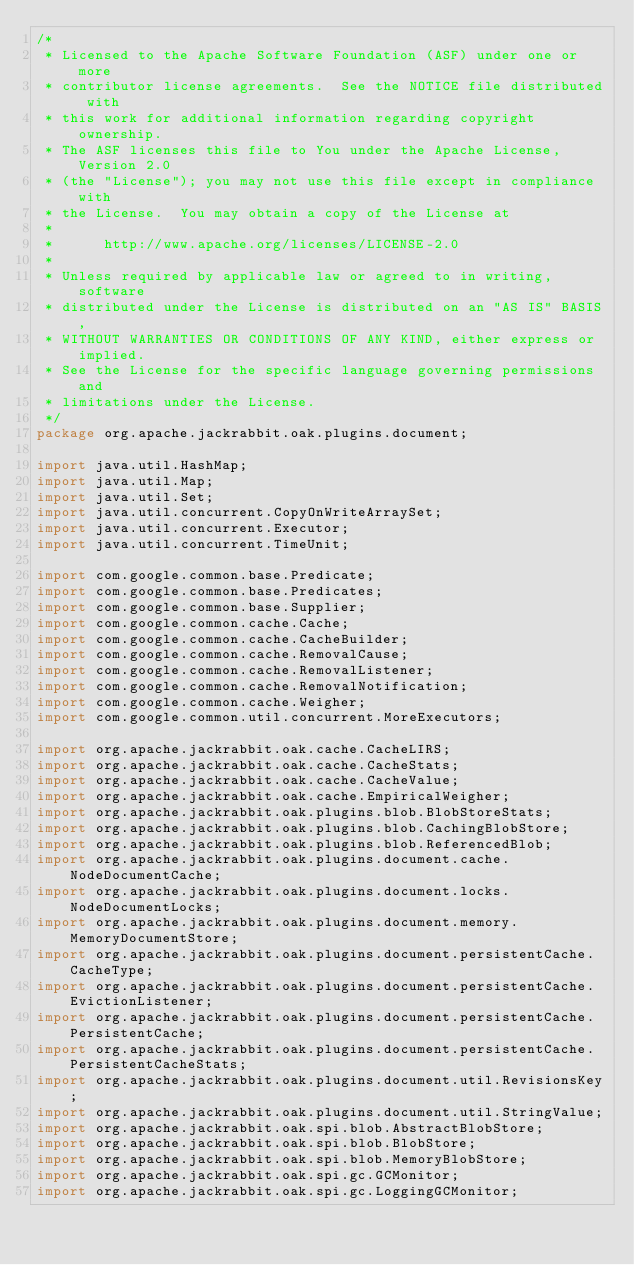<code> <loc_0><loc_0><loc_500><loc_500><_Java_>/*
 * Licensed to the Apache Software Foundation (ASF) under one or more
 * contributor license agreements.  See the NOTICE file distributed with
 * this work for additional information regarding copyright ownership.
 * The ASF licenses this file to You under the Apache License, Version 2.0
 * (the "License"); you may not use this file except in compliance with
 * the License.  You may obtain a copy of the License at
 *
 *      http://www.apache.org/licenses/LICENSE-2.0
 *
 * Unless required by applicable law or agreed to in writing, software
 * distributed under the License is distributed on an "AS IS" BASIS,
 * WITHOUT WARRANTIES OR CONDITIONS OF ANY KIND, either express or implied.
 * See the License for the specific language governing permissions and
 * limitations under the License.
 */
package org.apache.jackrabbit.oak.plugins.document;

import java.util.HashMap;
import java.util.Map;
import java.util.Set;
import java.util.concurrent.CopyOnWriteArraySet;
import java.util.concurrent.Executor;
import java.util.concurrent.TimeUnit;

import com.google.common.base.Predicate;
import com.google.common.base.Predicates;
import com.google.common.base.Supplier;
import com.google.common.cache.Cache;
import com.google.common.cache.CacheBuilder;
import com.google.common.cache.RemovalCause;
import com.google.common.cache.RemovalListener;
import com.google.common.cache.RemovalNotification;
import com.google.common.cache.Weigher;
import com.google.common.util.concurrent.MoreExecutors;

import org.apache.jackrabbit.oak.cache.CacheLIRS;
import org.apache.jackrabbit.oak.cache.CacheStats;
import org.apache.jackrabbit.oak.cache.CacheValue;
import org.apache.jackrabbit.oak.cache.EmpiricalWeigher;
import org.apache.jackrabbit.oak.plugins.blob.BlobStoreStats;
import org.apache.jackrabbit.oak.plugins.blob.CachingBlobStore;
import org.apache.jackrabbit.oak.plugins.blob.ReferencedBlob;
import org.apache.jackrabbit.oak.plugins.document.cache.NodeDocumentCache;
import org.apache.jackrabbit.oak.plugins.document.locks.NodeDocumentLocks;
import org.apache.jackrabbit.oak.plugins.document.memory.MemoryDocumentStore;
import org.apache.jackrabbit.oak.plugins.document.persistentCache.CacheType;
import org.apache.jackrabbit.oak.plugins.document.persistentCache.EvictionListener;
import org.apache.jackrabbit.oak.plugins.document.persistentCache.PersistentCache;
import org.apache.jackrabbit.oak.plugins.document.persistentCache.PersistentCacheStats;
import org.apache.jackrabbit.oak.plugins.document.util.RevisionsKey;
import org.apache.jackrabbit.oak.plugins.document.util.StringValue;
import org.apache.jackrabbit.oak.spi.blob.AbstractBlobStore;
import org.apache.jackrabbit.oak.spi.blob.BlobStore;
import org.apache.jackrabbit.oak.spi.blob.MemoryBlobStore;
import org.apache.jackrabbit.oak.spi.gc.GCMonitor;
import org.apache.jackrabbit.oak.spi.gc.LoggingGCMonitor;</code> 